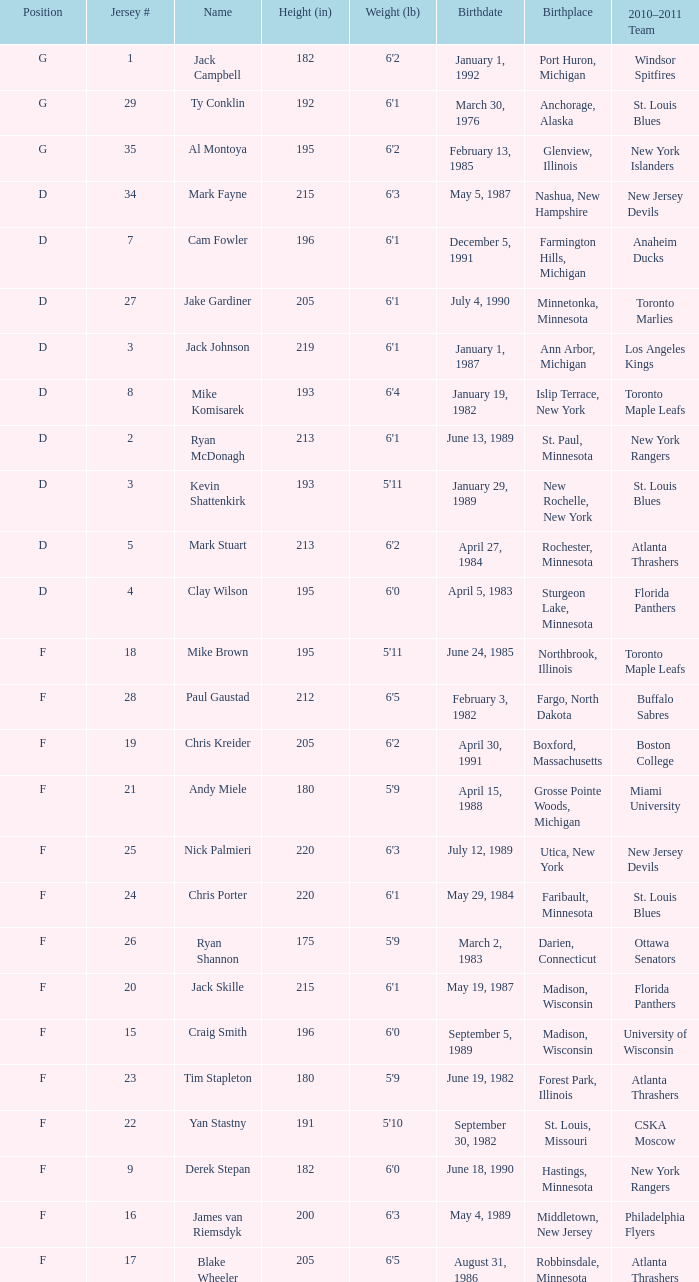Which birthplace's height in inches was more than 192 when the position was d and the birthday was April 5, 1983? Sturgeon Lake, Minnesota. 